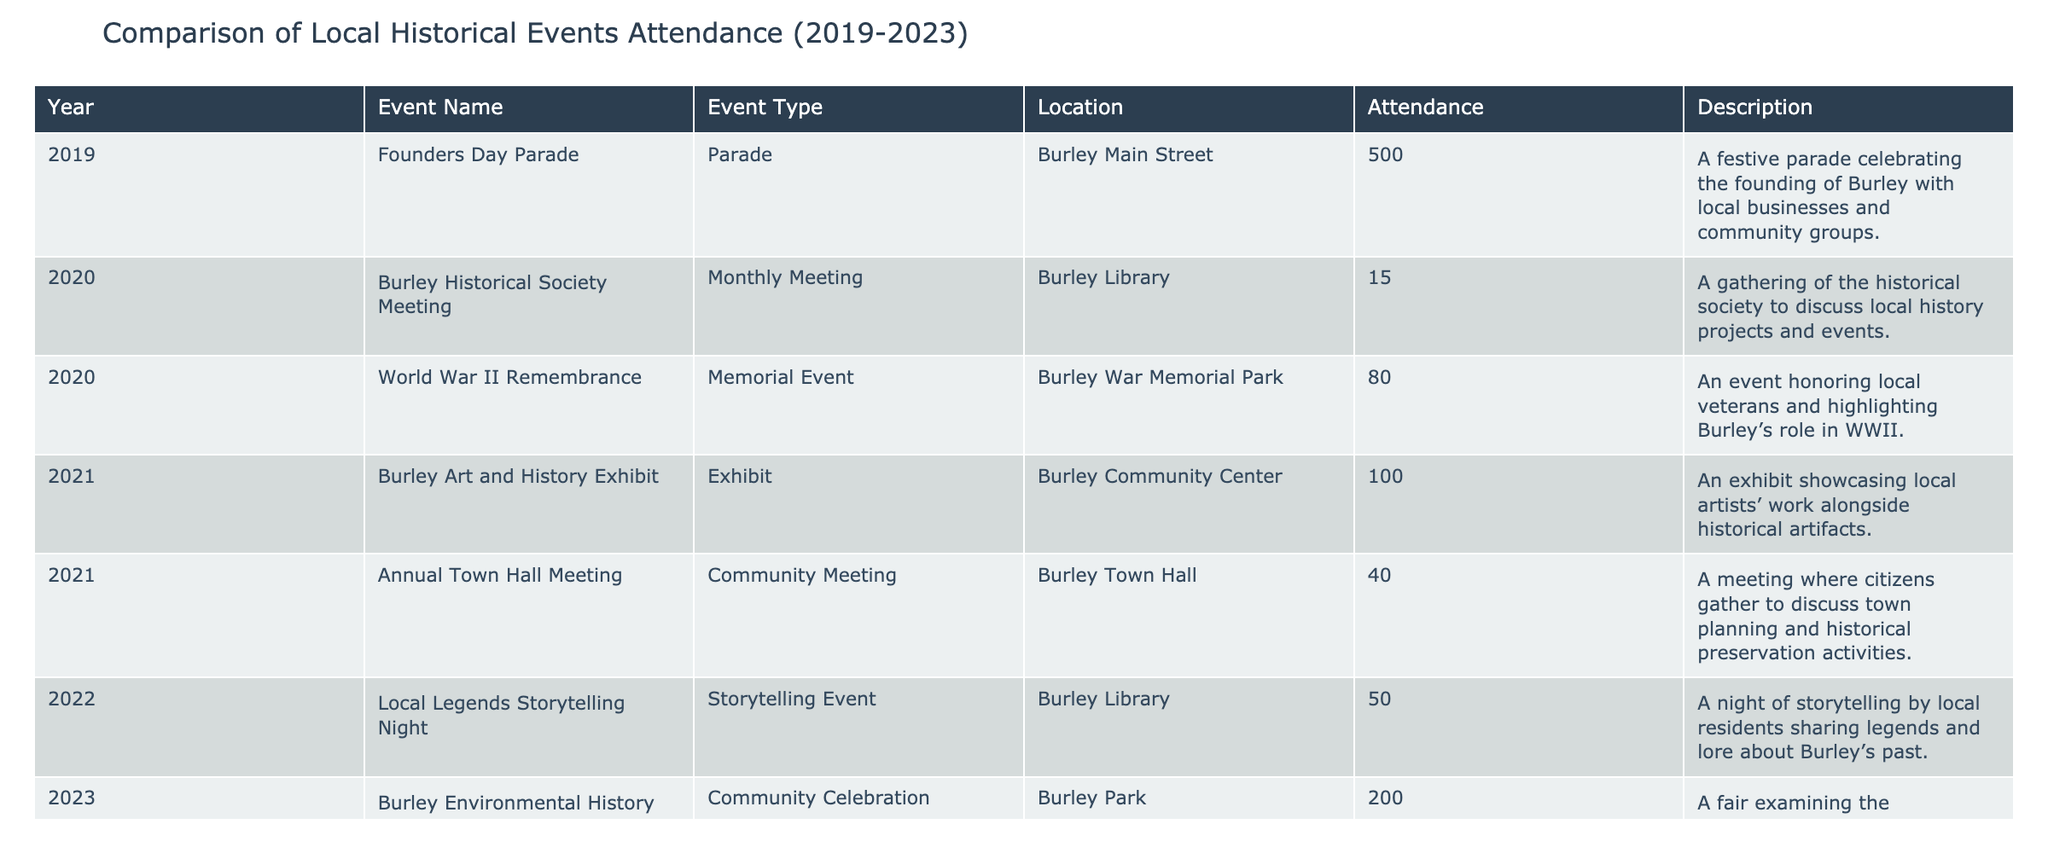What was the highest attendance for an event in 2023? The table shows that the Burley Environmental History Fair had the highest attendance in 2023 with a total of 200 participants.
Answer: 200 How many total attendees participated in events in 2021? The events in 2021 are the Burley Art and History Exhibit (100 attendees) and the Annual Town Hall Meeting (40 attendees). Summing these gives 100 + 40 = 140.
Answer: 140 Was there an event with attendance over 500 in the last five years? The highest attendance recorded is 500 for the Founders Day Parade in 2019, indicating that no events exceeded this figure in the given period.
Answer: No What is the average attendance across all events listed in 2020? In 2020, there were two events: Burley Historical Society Meeting (15 attendees) and World War II Remembrance (80 attendees). The total attendance is 15 + 80 = 95, and the average is 95/2 = 47.5.
Answer: 47.5 Which event type had the highest attendance overall? Comparing attendance figures, the Founders Day Parade (500, Parade) has the highest attendance. No other events match this attendance level across all types.
Answer: Parade What was the difference in attendance between the highest and lowest events in 2022? In 2022, the Local Legends Storytelling Night had 50 attendees. Since there’s only one event reported, we can’t calculate a difference as there’s no second data point. Thus, we conclude attendance does not change.
Answer: 0 If we consider only the workshop events, what was the total attendance from 2023? The table lists the Heritage Preservation Workshop with an attendance of 30. Since it's the only workshop in 2023, the total attendance is simply 30.
Answer: 30 How many events had attendance counts below 100 over the last five years? The events with attendance below 100 are the Burley Historical Society Meeting (15), World War II Remembrance (80), Annual Town Hall Meeting (40), and Local Legends Storytelling Night (50), totaling 4 such events.
Answer: 4 What percentage of the total attendance in 2019 was accounted for by the Founders Day Parade? Since the Founders Day Parade had an attendance of 500 in 2019 and it was the only event recorded that year, it accounted for 100% of the attendance.
Answer: 100% How did attendance in 2023 compare to 2021? In 2023, the total attendance is from two events: Burley Environmental History Fair (200) and Heritage Preservation Workshop (30), totaling 230. In 2021, there were two events with a total attendance of 140. The difference is 230 - 140 = 90, indicating an increase.
Answer: Increased by 90 